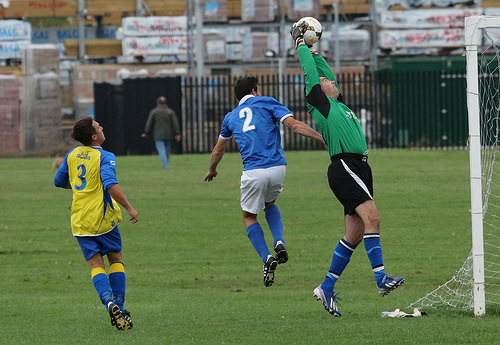<image>
Can you confirm if the player is to the left of the player? No. The player is not to the left of the player. From this viewpoint, they have a different horizontal relationship. Is the ball in front of the man? No. The ball is not in front of the man. The spatial positioning shows a different relationship between these objects. 